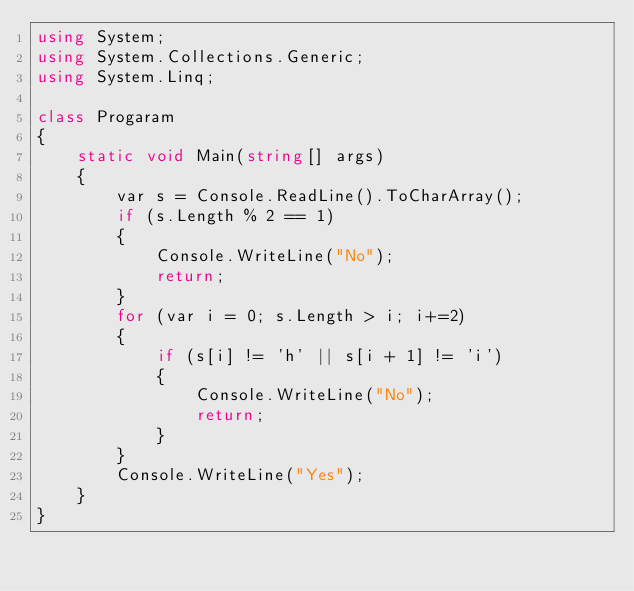Convert code to text. <code><loc_0><loc_0><loc_500><loc_500><_C#_>using System;
using System.Collections.Generic;
using System.Linq;

class Progaram
{
    static void Main(string[] args)
    {
        var s = Console.ReadLine().ToCharArray();
        if (s.Length % 2 == 1)
        {
            Console.WriteLine("No");
            return;
        }
        for (var i = 0; s.Length > i; i+=2)
        {
            if (s[i] != 'h' || s[i + 1] != 'i')
            {
                Console.WriteLine("No");
                return;
            }
        }
        Console.WriteLine("Yes");
    }
}
</code> 